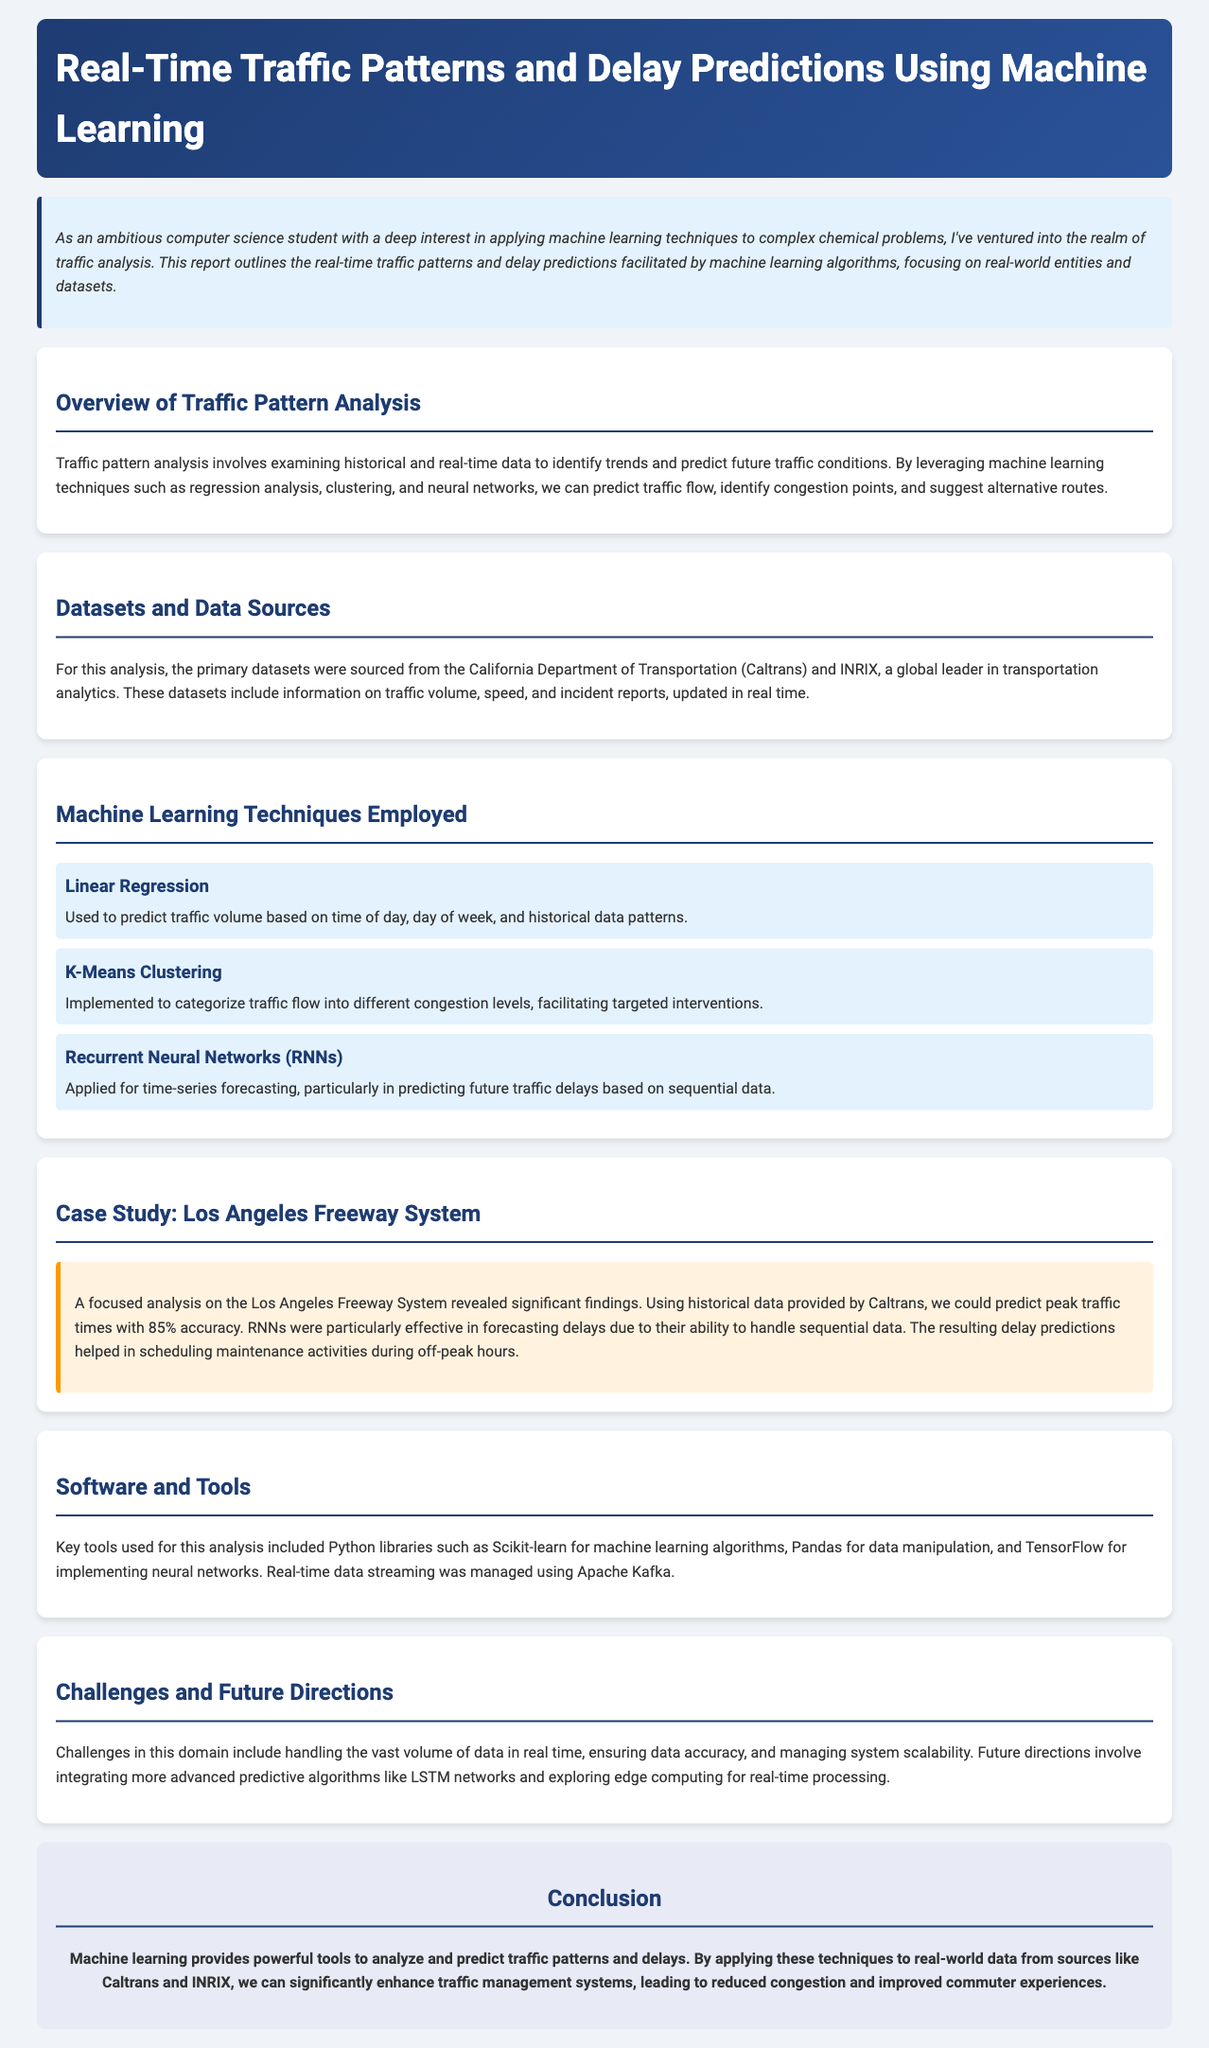What is the main focus of the report? The report outlines real-time traffic patterns and delay predictions facilitated by machine learning algorithms.
Answer: Traffic patterns and delay predictions What datasets were used for the analysis? The primary datasets were sourced from the California Department of Transportation and INRIX.
Answer: Caltrans and INRIX What machine learning technique was used for time-series forecasting? Recurrent Neural Networks (RNNs) were applied for time-series forecasting.
Answer: Recurrent Neural Networks What percentage accuracy was achieved in predicting peak traffic times? The analysis revealed significant findings with 85% accuracy in predicting peak traffic times.
Answer: 85% Which Python libraries were mentioned as tools used for analysis? Key tools included Scikit-learn, Pandas, and TensorFlow.
Answer: Scikit-learn, Pandas, TensorFlow What is one of the challenges mentioned in the report? A challenge in this domain includes handling the vast volume of data in real time.
Answer: Vast volume of data What is the conclusion drawn in the report? Machine learning provides powerful tools to analyze and predict traffic patterns and delays.
Answer: Powerful tools for traffic analysis What type of analysis was conducted in the case study? A focused analysis on the Los Angeles Freeway System revealed significant findings.
Answer: Los Angeles Freeway System 